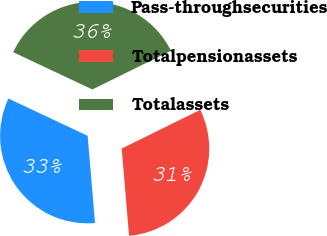<chart> <loc_0><loc_0><loc_500><loc_500><pie_chart><fcel>Pass-throughsecurities<fcel>Totalpensionassets<fcel>Totalassets<nl><fcel>33.33%<fcel>30.95%<fcel>35.71%<nl></chart> 